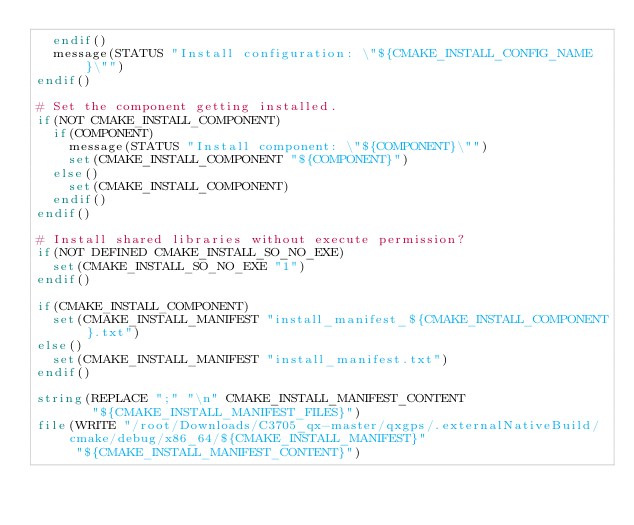Convert code to text. <code><loc_0><loc_0><loc_500><loc_500><_CMake_>  endif()
  message(STATUS "Install configuration: \"${CMAKE_INSTALL_CONFIG_NAME}\"")
endif()

# Set the component getting installed.
if(NOT CMAKE_INSTALL_COMPONENT)
  if(COMPONENT)
    message(STATUS "Install component: \"${COMPONENT}\"")
    set(CMAKE_INSTALL_COMPONENT "${COMPONENT}")
  else()
    set(CMAKE_INSTALL_COMPONENT)
  endif()
endif()

# Install shared libraries without execute permission?
if(NOT DEFINED CMAKE_INSTALL_SO_NO_EXE)
  set(CMAKE_INSTALL_SO_NO_EXE "1")
endif()

if(CMAKE_INSTALL_COMPONENT)
  set(CMAKE_INSTALL_MANIFEST "install_manifest_${CMAKE_INSTALL_COMPONENT}.txt")
else()
  set(CMAKE_INSTALL_MANIFEST "install_manifest.txt")
endif()

string(REPLACE ";" "\n" CMAKE_INSTALL_MANIFEST_CONTENT
       "${CMAKE_INSTALL_MANIFEST_FILES}")
file(WRITE "/root/Downloads/C3705_qx-master/qxgps/.externalNativeBuild/cmake/debug/x86_64/${CMAKE_INSTALL_MANIFEST}"
     "${CMAKE_INSTALL_MANIFEST_CONTENT}")
</code> 